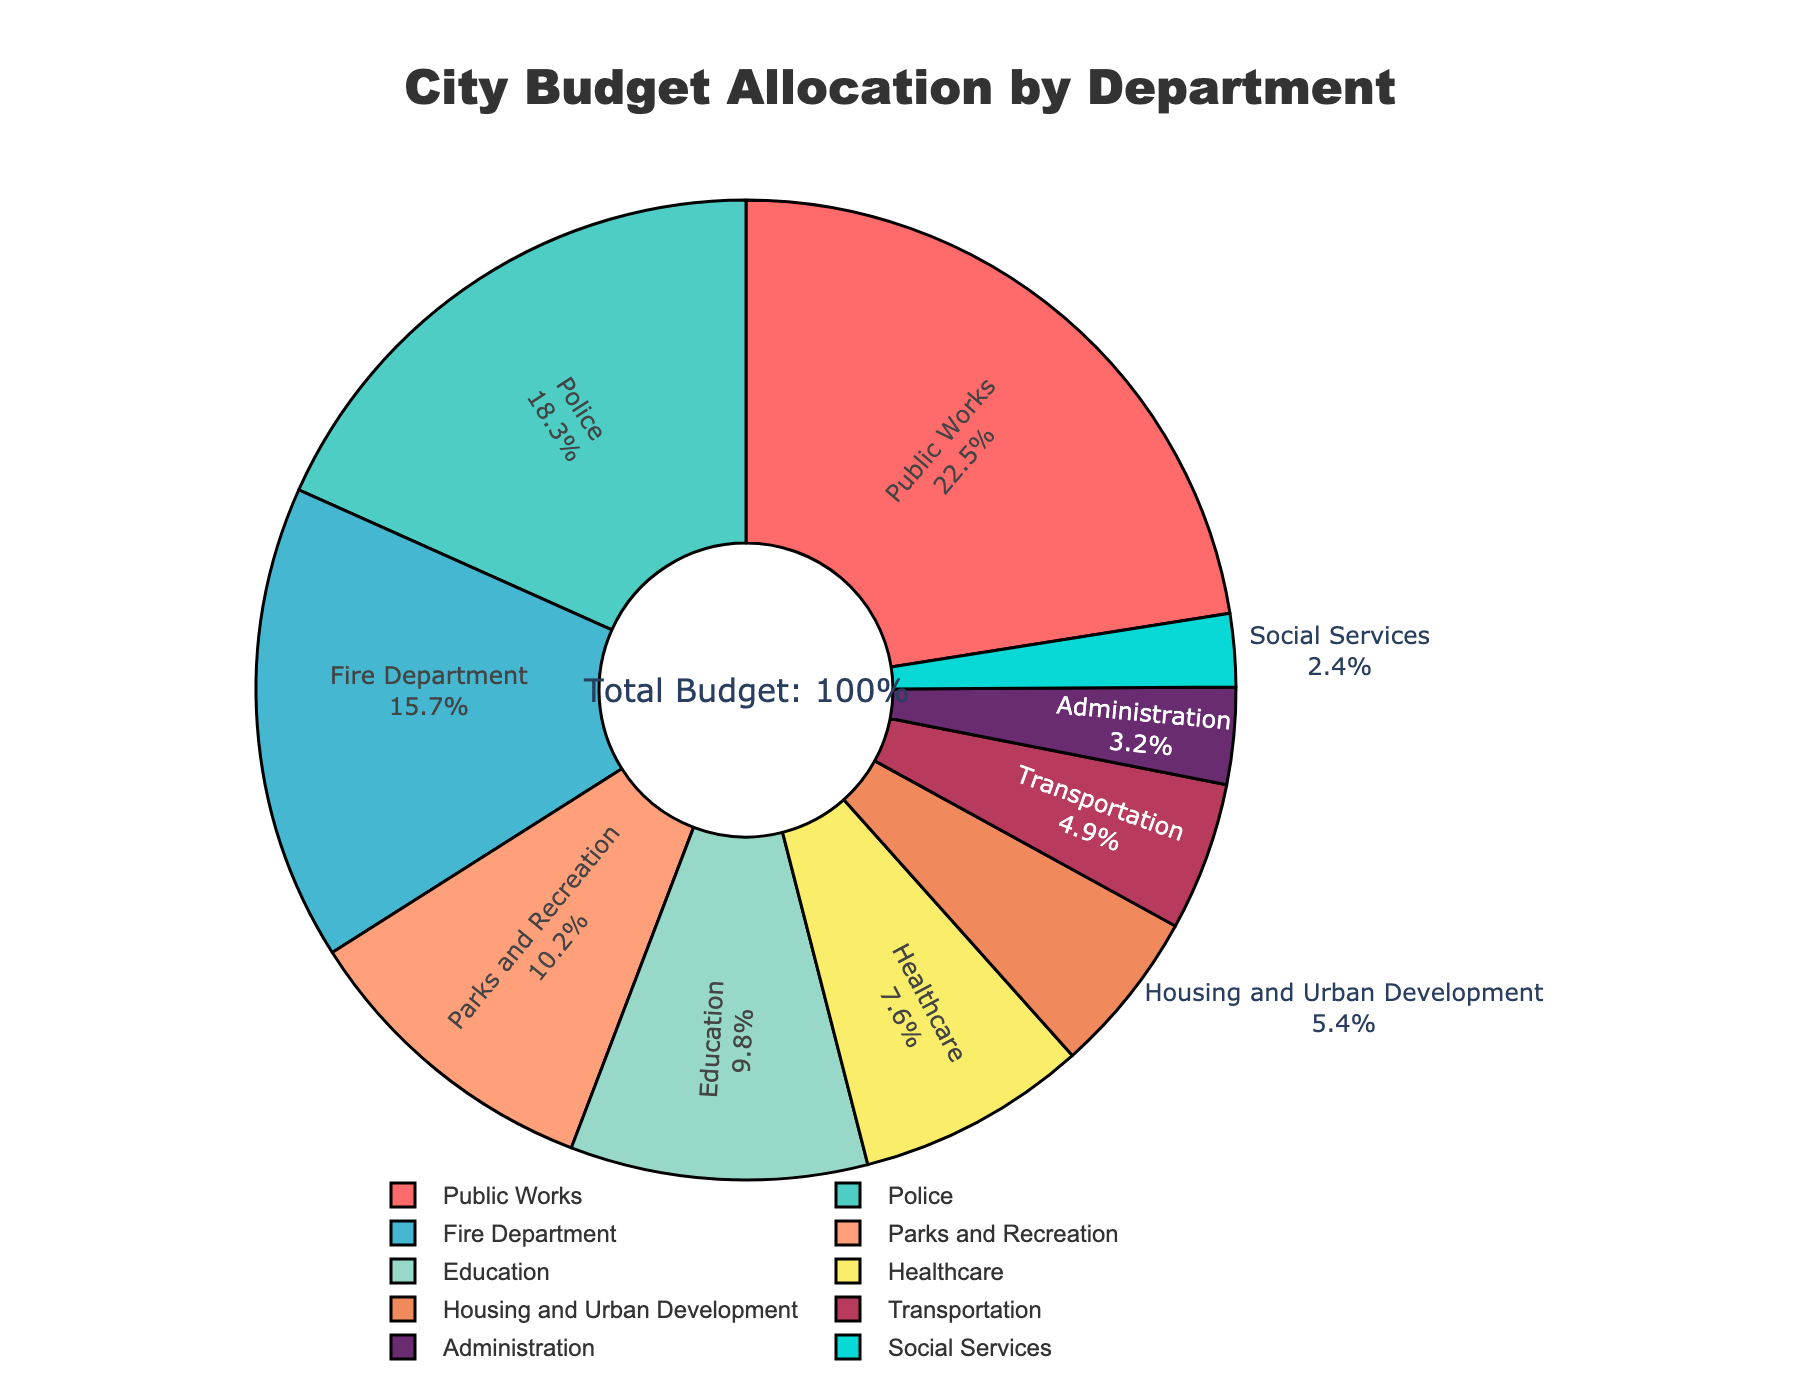What percentage of the budget is allocated to Public Works and the Police combined? Sum the percentage allocations for Public Works (22.5%) and Police (18.3%). The combined allocation is 22.5% + 18.3% = 40.8%.
Answer: 40.8% Which department has a higher budget allocation, Healthcare or Housing and Urban Development? Compare the budget allocations for Healthcare (7.6%) and Housing and Urban Development (5.4%). Since 7.6% is greater than 5.4%, Healthcare has a higher allocation.
Answer: Healthcare Which department has the smallest budget allocation, and what is its percentage? Identify the department with the smallest percentage allocation from the pie chart. Social Services has the lowest allocation at 2.4%.
Answer: Social Services, 2.4% By how much does the budget allocation for Education differ from that for Transportation? Subtract the budget allocation for Transportation (4.9%) from that for Education (9.8%). The difference is 9.8% - 4.9% = 4.9%.
Answer: 4.9% What is the combined budget allocation for departments related to emergency services (Police and Fire Department)? Sum the budget allocations for Police (18.3%) and Fire Department (15.7%). The combined allocation is 18.3% + 15.7% = 34.0%.
Answer: 34.0% Is the budget allocation for Parks and Recreation greater or lesser than the sum of allocations for Administration and Social Services? Compare the allocation for Parks and Recreation (10.2%) with the sum of allocations for Administration (3.2%) and Social Services (2.4%). Since 10.2% is greater than the sum (3.2% + 2.4% = 5.6%), Parks and Recreation has a greater allocation.
Answer: Greater Which department has the highest budget allocation, and what percentage of the total budget does it represent? Identify the department with the highest budget allocation from the pie chart. Public Works has the highest allocation at 22.5%.
Answer: Public Works, 22.5% Calculate the total budget allocation percentage for all departments listed in the pie chart. Sum all the budget allocations: 22.5% + 18.3% + 15.7% + 10.2% + 9.8% + 7.6% + 5.4% + 4.9% + 3.2% + 2.4% = 100%.
Answer: 100% How does the allocation for the Fire Department compare to the combined allocation for Housing and Urban Development and Administration? Compare the allocation for the Fire Department (15.7%) with the sum of allocations for Housing and Urban Development (5.4%) and Administration (3.2%). Since 15.7% is greater than the sum (5.4% + 3.2% = 8.6%), the Fire Department has a higher allocation.
Answer: Higher What is the average budget allocation for Transportation, Administration, and Social Services combined? Calculate the mean of the budget allocations for Transportation (4.9%), Administration (3.2%), and Social Services (2.4%). The sum is 4.9% + 3.2% + 2.4% = 10.5%, and the average is 10.5% / 3 = 3.5%.
Answer: 3.5% 